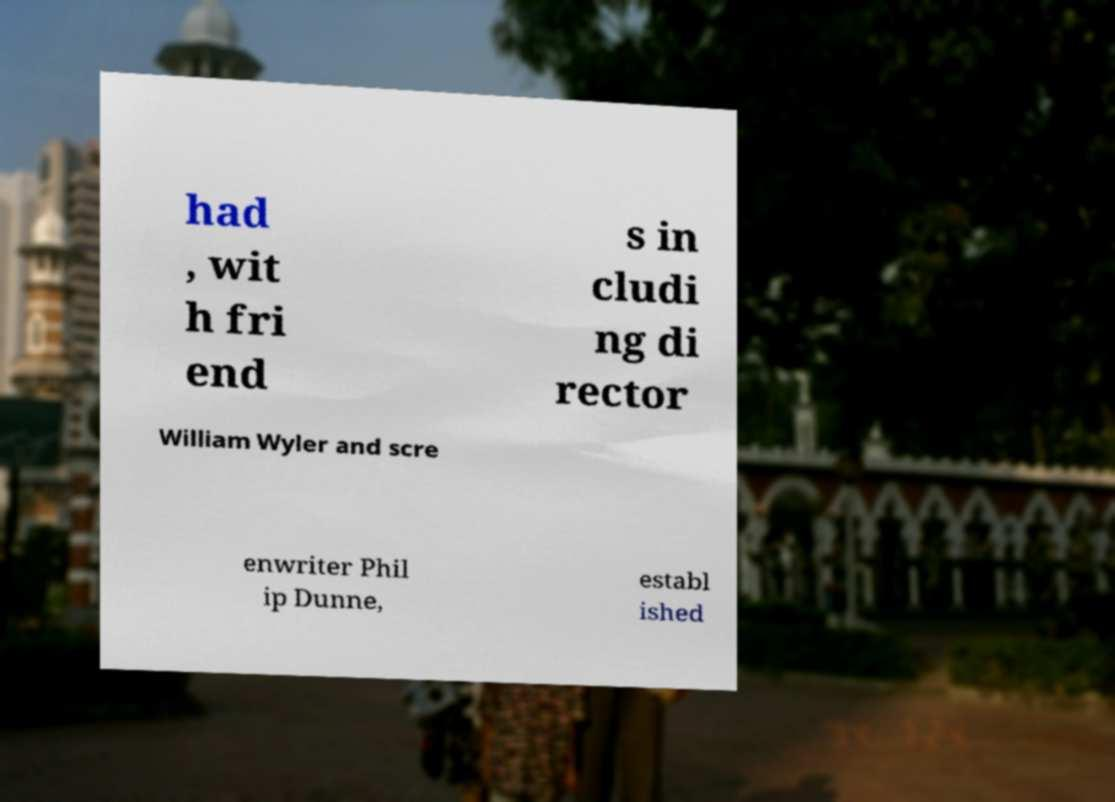Can you read and provide the text displayed in the image?This photo seems to have some interesting text. Can you extract and type it out for me? had , wit h fri end s in cludi ng di rector William Wyler and scre enwriter Phil ip Dunne, establ ished 